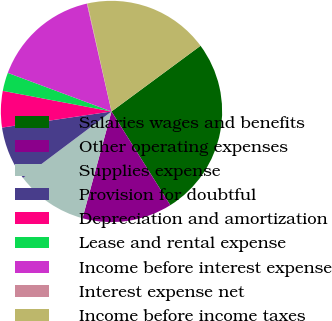<chart> <loc_0><loc_0><loc_500><loc_500><pie_chart><fcel>Salaries wages and benefits<fcel>Other operating expenses<fcel>Supplies expense<fcel>Provision for doubtful<fcel>Depreciation and amortization<fcel>Lease and rental expense<fcel>Income before interest expense<fcel>Interest expense net<fcel>Income before income taxes<nl><fcel>26.2%<fcel>13.14%<fcel>10.53%<fcel>7.92%<fcel>5.31%<fcel>2.69%<fcel>15.76%<fcel>0.08%<fcel>18.37%<nl></chart> 